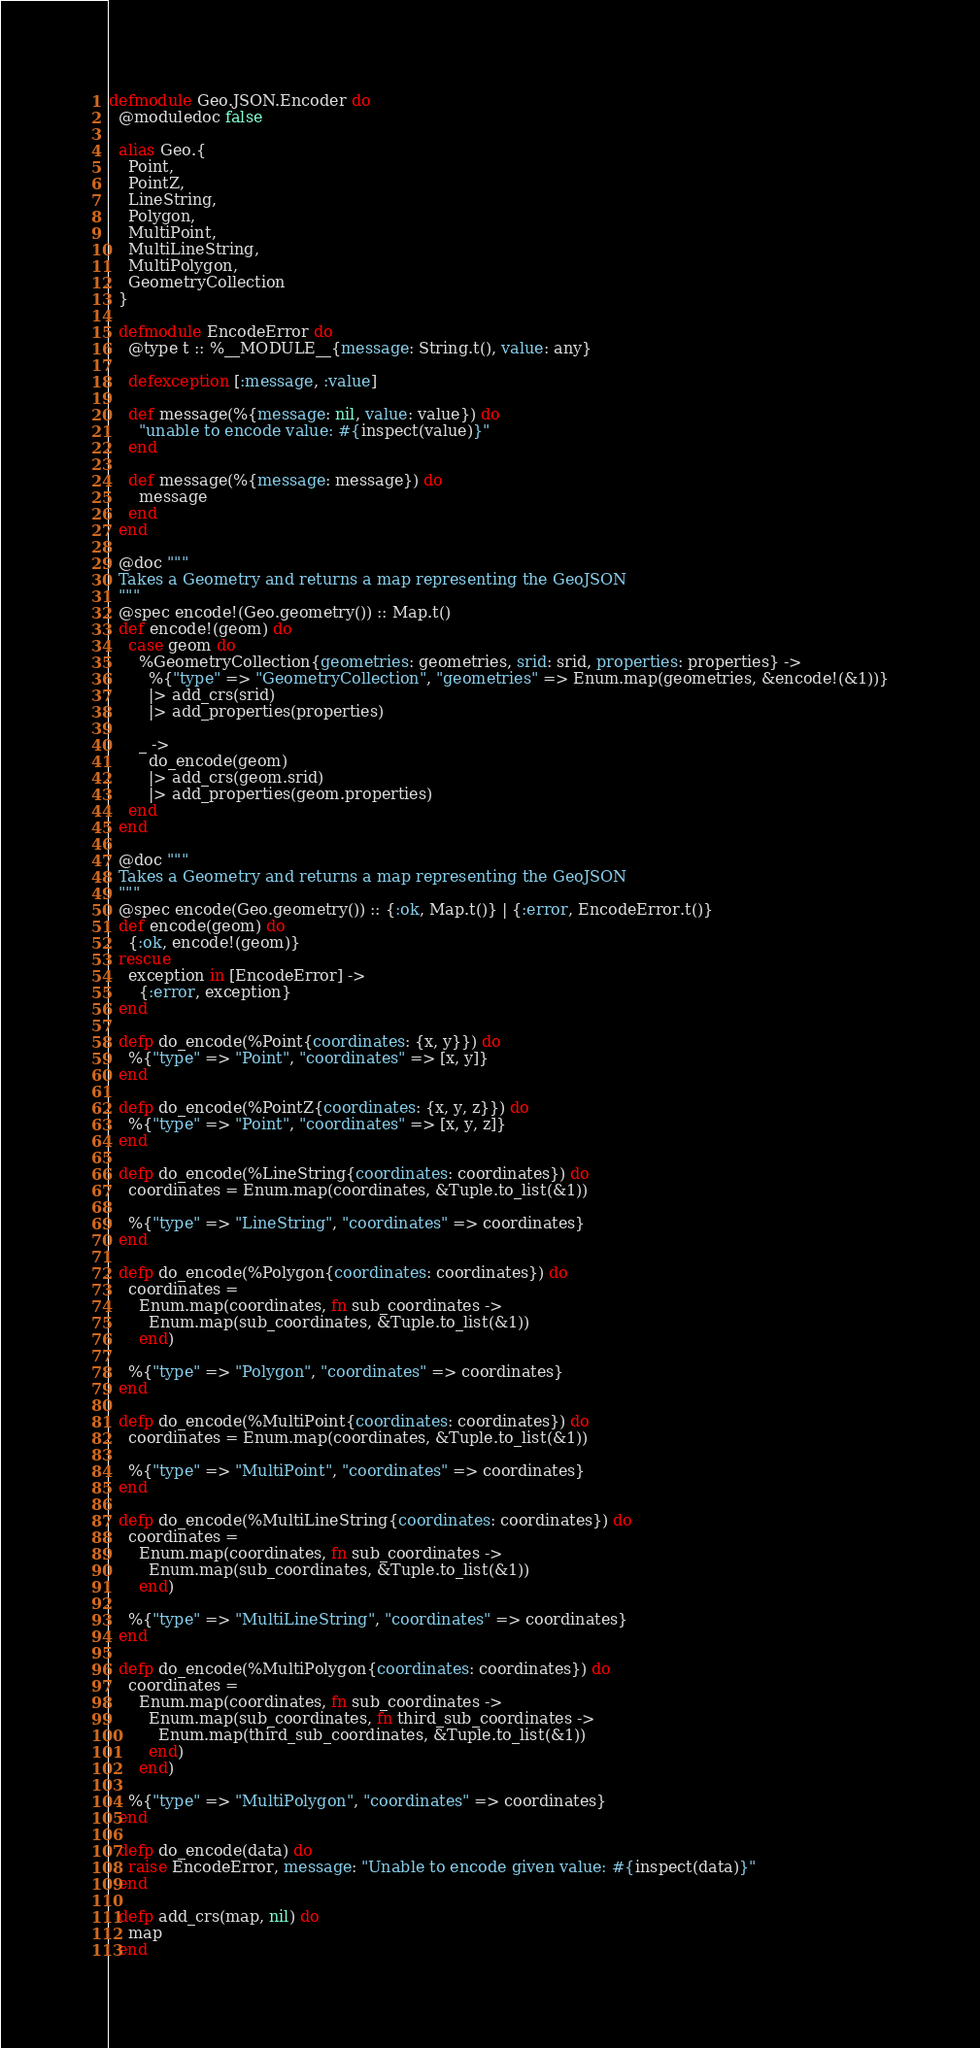Convert code to text. <code><loc_0><loc_0><loc_500><loc_500><_Elixir_>defmodule Geo.JSON.Encoder do
  @moduledoc false

  alias Geo.{
    Point,
    PointZ,
    LineString,
    Polygon,
    MultiPoint,
    MultiLineString,
    MultiPolygon,
    GeometryCollection
  }

  defmodule EncodeError do
    @type t :: %__MODULE__{message: String.t(), value: any}

    defexception [:message, :value]

    def message(%{message: nil, value: value}) do
      "unable to encode value: #{inspect(value)}"
    end

    def message(%{message: message}) do
      message
    end
  end

  @doc """
  Takes a Geometry and returns a map representing the GeoJSON
  """
  @spec encode!(Geo.geometry()) :: Map.t()
  def encode!(geom) do
    case geom do
      %GeometryCollection{geometries: geometries, srid: srid, properties: properties} ->
        %{"type" => "GeometryCollection", "geometries" => Enum.map(geometries, &encode!(&1))}
        |> add_crs(srid)
        |> add_properties(properties)

      _ ->
        do_encode(geom)
        |> add_crs(geom.srid)
        |> add_properties(geom.properties)
    end
  end

  @doc """
  Takes a Geometry and returns a map representing the GeoJSON
  """
  @spec encode(Geo.geometry()) :: {:ok, Map.t()} | {:error, EncodeError.t()}
  def encode(geom) do
    {:ok, encode!(geom)}
  rescue
    exception in [EncodeError] ->
      {:error, exception}
  end

  defp do_encode(%Point{coordinates: {x, y}}) do
    %{"type" => "Point", "coordinates" => [x, y]}
  end

  defp do_encode(%PointZ{coordinates: {x, y, z}}) do
    %{"type" => "Point", "coordinates" => [x, y, z]}
  end

  defp do_encode(%LineString{coordinates: coordinates}) do
    coordinates = Enum.map(coordinates, &Tuple.to_list(&1))

    %{"type" => "LineString", "coordinates" => coordinates}
  end

  defp do_encode(%Polygon{coordinates: coordinates}) do
    coordinates =
      Enum.map(coordinates, fn sub_coordinates ->
        Enum.map(sub_coordinates, &Tuple.to_list(&1))
      end)

    %{"type" => "Polygon", "coordinates" => coordinates}
  end

  defp do_encode(%MultiPoint{coordinates: coordinates}) do
    coordinates = Enum.map(coordinates, &Tuple.to_list(&1))

    %{"type" => "MultiPoint", "coordinates" => coordinates}
  end

  defp do_encode(%MultiLineString{coordinates: coordinates}) do
    coordinates =
      Enum.map(coordinates, fn sub_coordinates ->
        Enum.map(sub_coordinates, &Tuple.to_list(&1))
      end)

    %{"type" => "MultiLineString", "coordinates" => coordinates}
  end

  defp do_encode(%MultiPolygon{coordinates: coordinates}) do
    coordinates =
      Enum.map(coordinates, fn sub_coordinates ->
        Enum.map(sub_coordinates, fn third_sub_coordinates ->
          Enum.map(third_sub_coordinates, &Tuple.to_list(&1))
        end)
      end)

    %{"type" => "MultiPolygon", "coordinates" => coordinates}
  end

  defp do_encode(data) do
    raise EncodeError, message: "Unable to encode given value: #{inspect(data)}"
  end

  defp add_crs(map, nil) do
    map
  end
</code> 